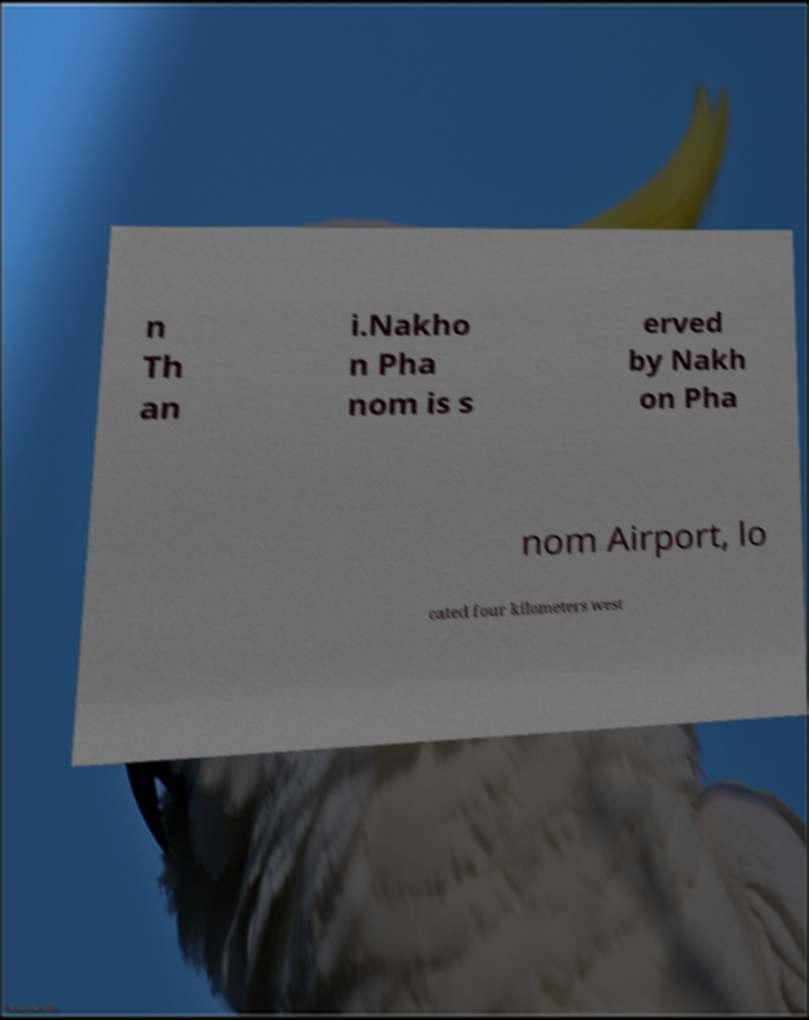Could you extract and type out the text from this image? n Th an i.Nakho n Pha nom is s erved by Nakh on Pha nom Airport, lo cated four kilometers west 